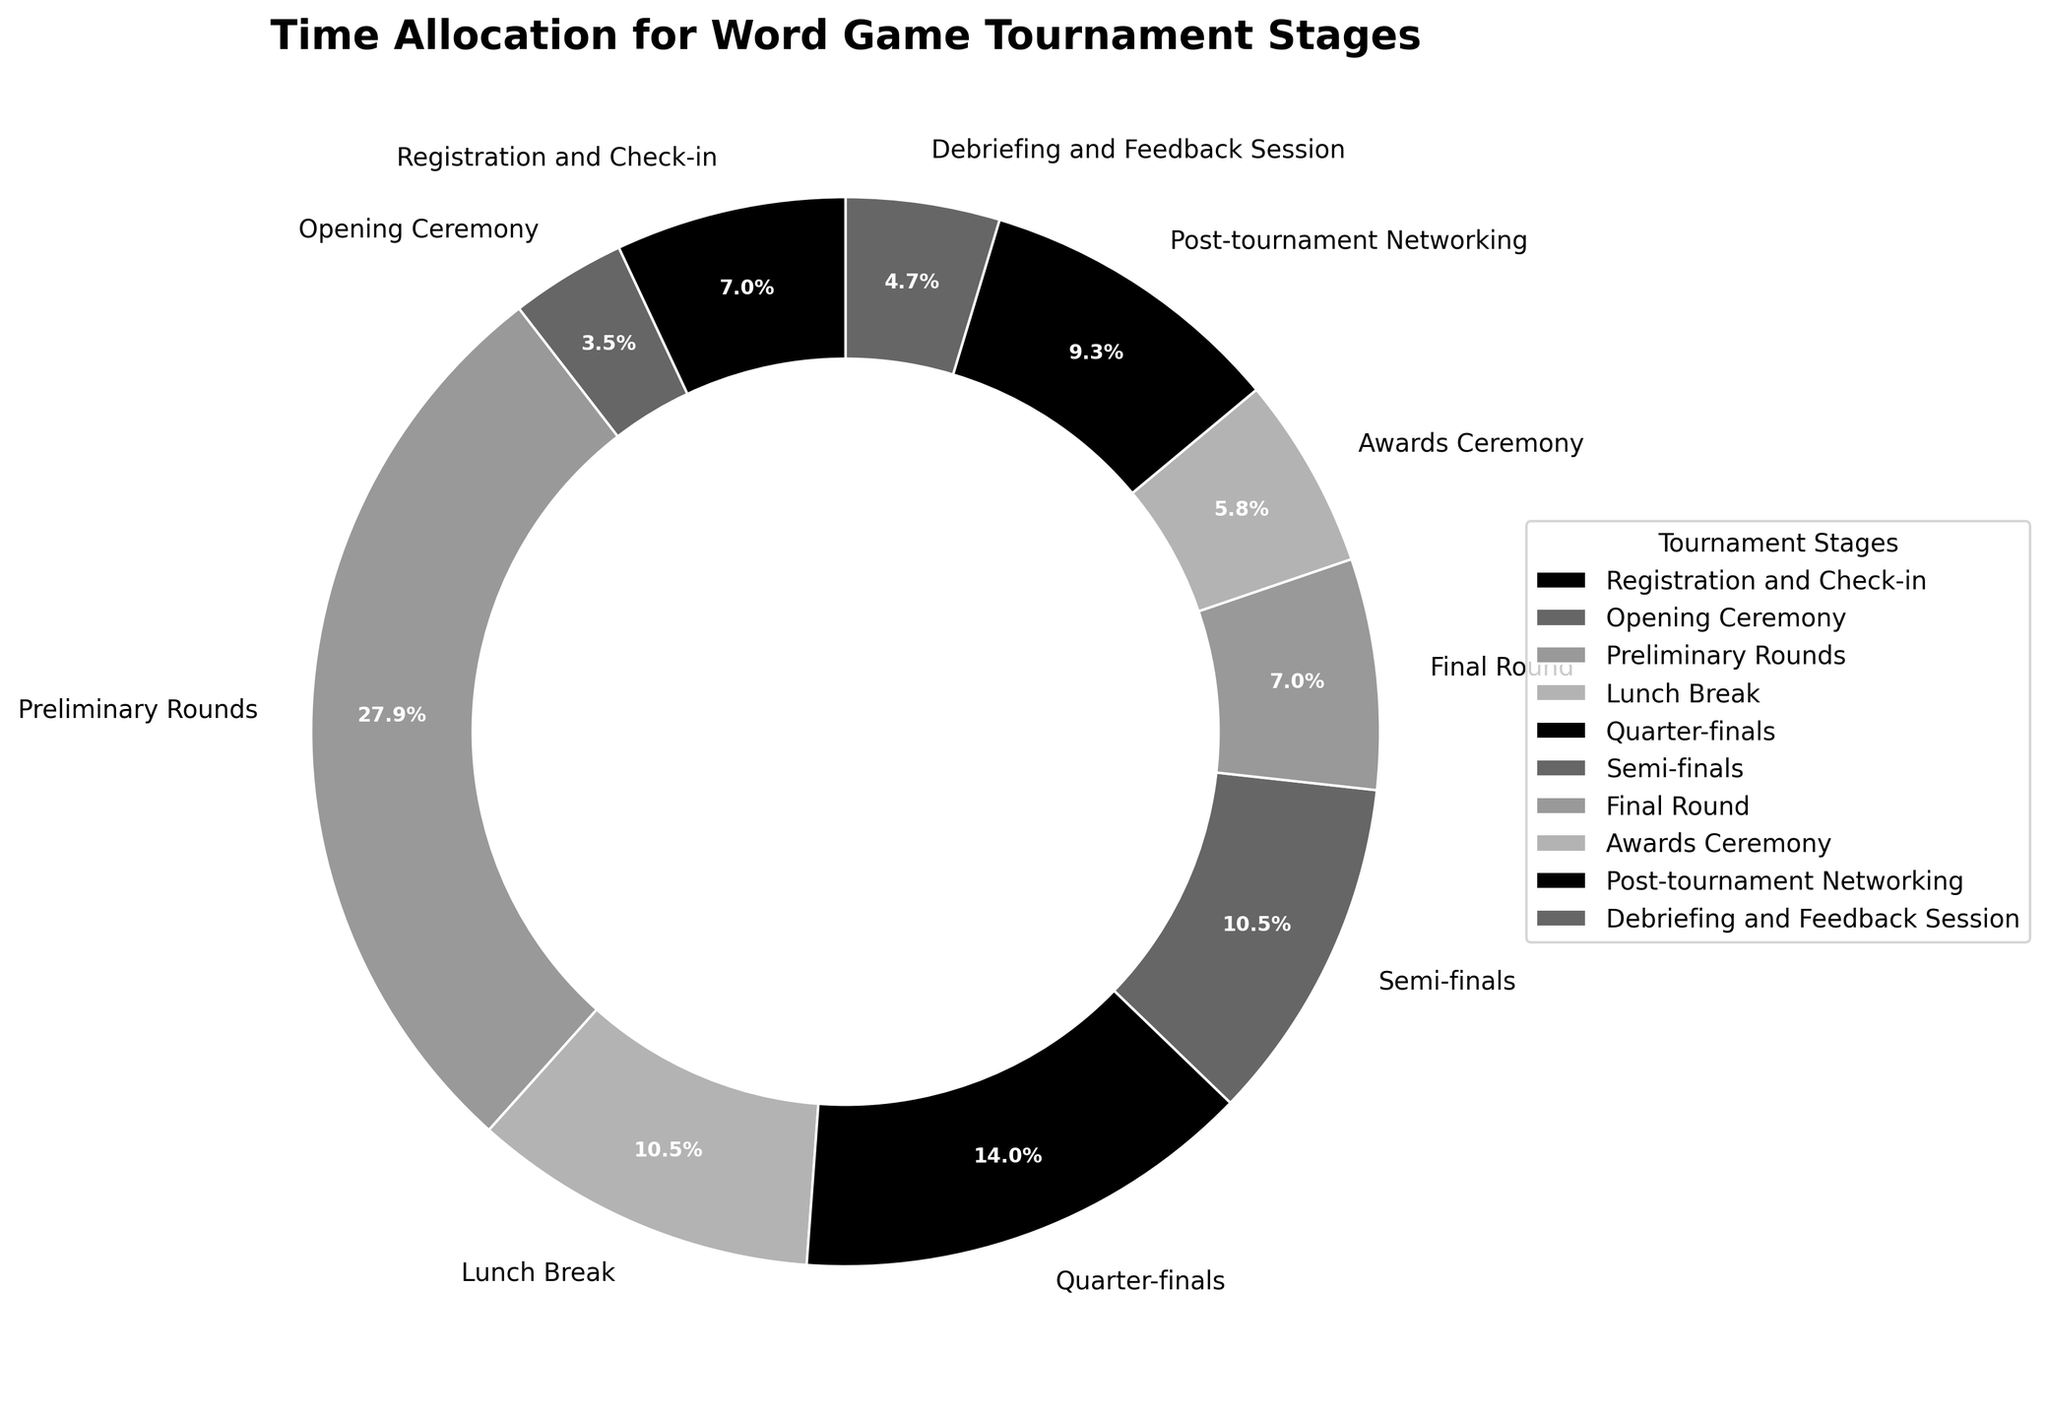Which stage in the tournament takes up the largest portion of time? By looking at the pie chart, we can see which wedge is the largest. The largest wedge represents the Preliminary Rounds.
Answer: Preliminary Rounds What is the combined time allocated for the Opening Ceremony and Award Ceremony? The time for the Opening Ceremony is 15 minutes and for the Award Ceremony is 25 minutes. Adding these together: 15 + 25 = 40 minutes.
Answer: 40 minutes How much more time is spent on the Preliminary Rounds compared to the Final Round? The Preliminary Rounds take 120 minutes, and the Final Round takes 30 minutes. Subtracting these gives: 120 - 30 = 90 minutes.
Answer: 90 minutes What percentage of the total time is spent on semi-finals? The total time is the sum of all the stages: 30 + 15 + 120 + 45 + 60 + 45 + 30 + 25 + 40 + 20 = 430 minutes. The Semi-finals take 45 minutes. The percentage is: (45 / 430) * 100 = 10.47%.
Answer: 10.47% Which stage takes up a smaller portion of time: Lunch Break or Post-tournament Networking? By comparing the wedges, the Lunch Break wedge is smaller than the Post-tournament Networking wedge.
Answer: Lunch Break What is the ratio of time spent on the Quarter-finals to the Debriefing and Feedback Session? The time for the Quarter-finals is 60 minutes and for the Debriefing and Feedback Session is 20 minutes. The ratio is 60:20, which simplifies to 3:1.
Answer: 3:1 If the Registration and Check-in stage were reduced by 10 minutes, how would the total time change? The current total time is 430 minutes. Reducing Registration and Check-in by 10 minutes changes it from 30 to 20 minutes. The new total time is 430 - 10 = 420 minutes.
Answer: 420 minutes Between the Opening Ceremony and Debriefing and Feedback Session, which stage has the shorter duration, and by how many minutes? The Opening Ceremony takes 15 minutes, while the Debriefing and Feedback Session takes 20 minutes. The difference is 20 - 15 = 5 minutes. The Opening Ceremony is shorter.
Answer: 5 minutes 